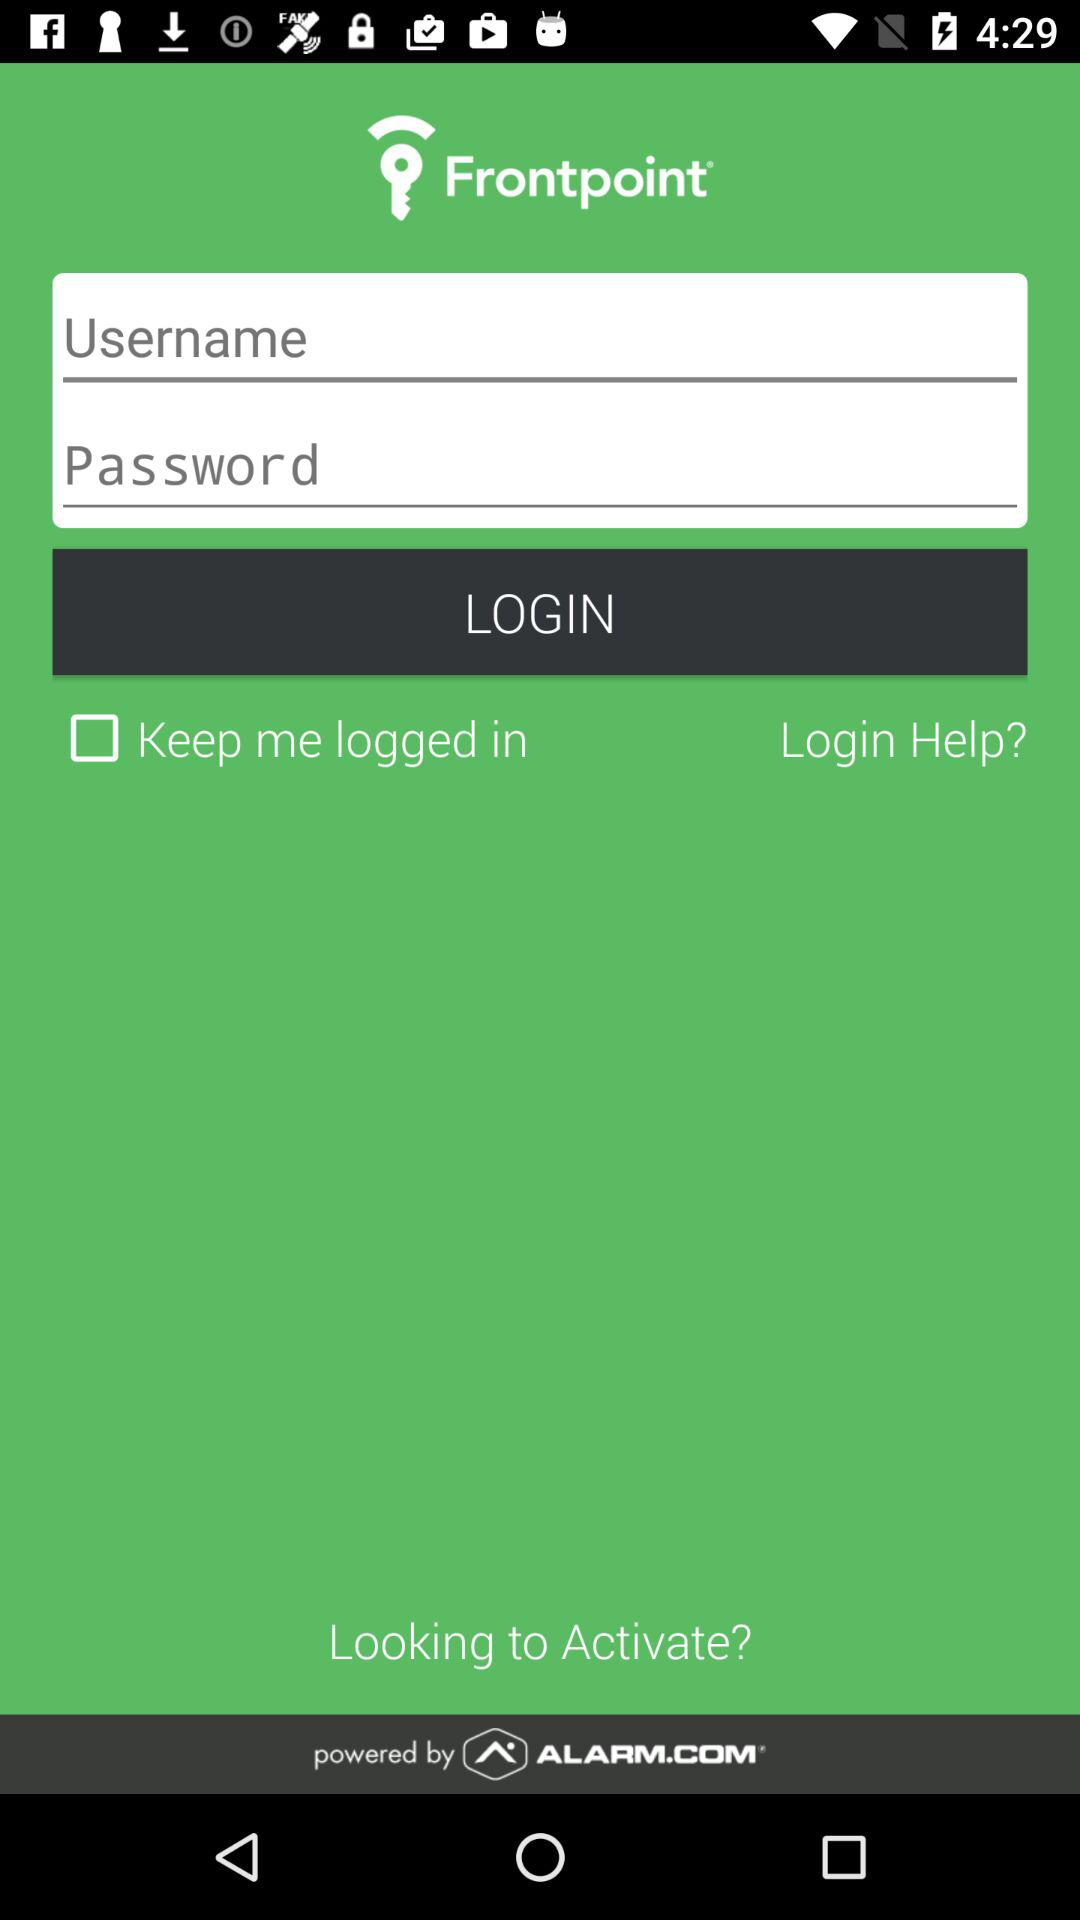How many more login fields are there than checkboxes?
Answer the question using a single word or phrase. 1 